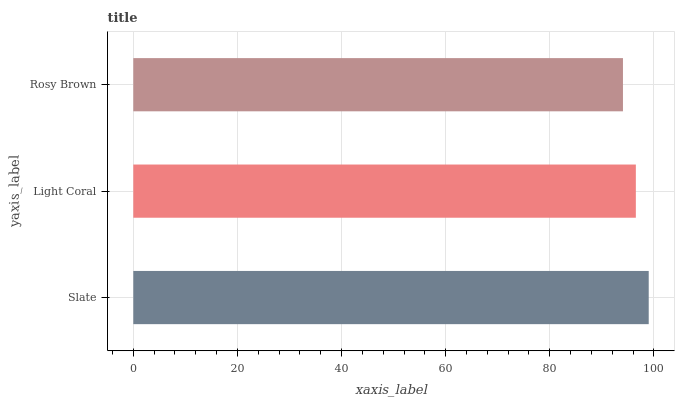Is Rosy Brown the minimum?
Answer yes or no. Yes. Is Slate the maximum?
Answer yes or no. Yes. Is Light Coral the minimum?
Answer yes or no. No. Is Light Coral the maximum?
Answer yes or no. No. Is Slate greater than Light Coral?
Answer yes or no. Yes. Is Light Coral less than Slate?
Answer yes or no. Yes. Is Light Coral greater than Slate?
Answer yes or no. No. Is Slate less than Light Coral?
Answer yes or no. No. Is Light Coral the high median?
Answer yes or no. Yes. Is Light Coral the low median?
Answer yes or no. Yes. Is Slate the high median?
Answer yes or no. No. Is Slate the low median?
Answer yes or no. No. 